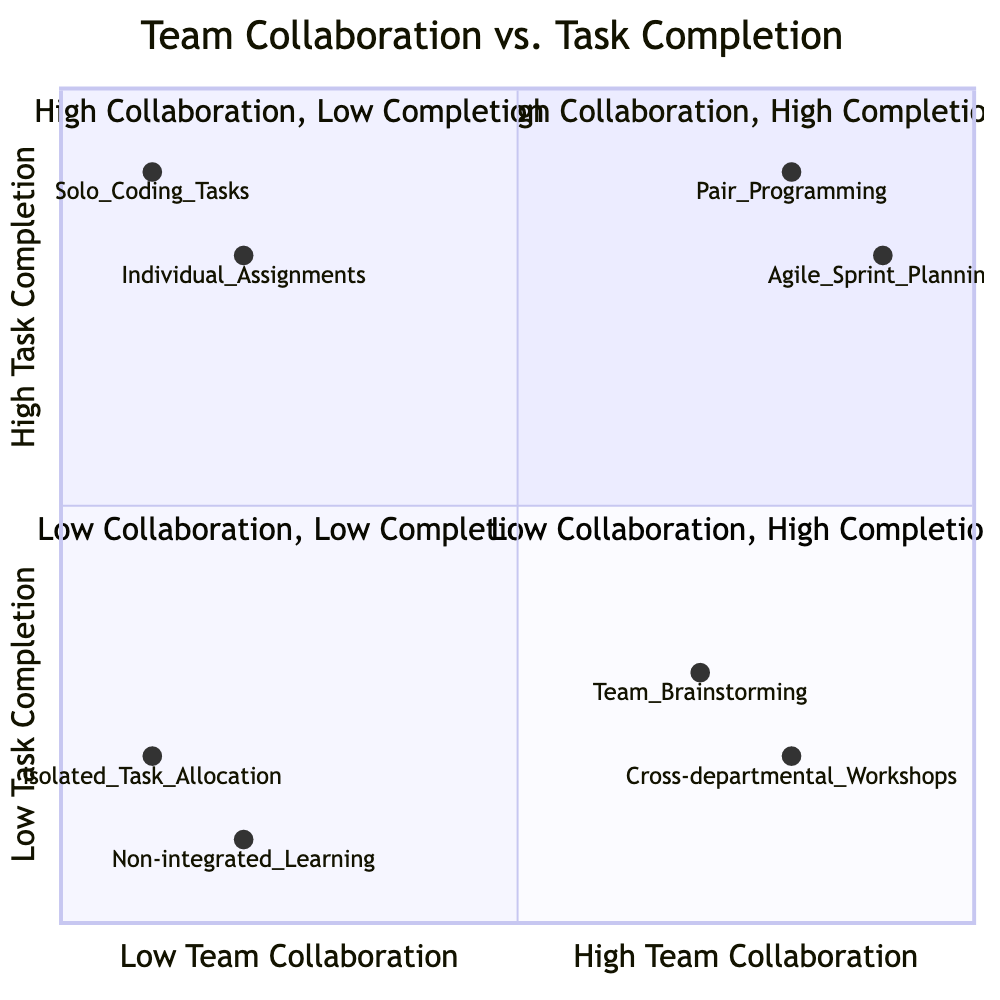What elements are in the "High Team Collaboration, High Task Completion" quadrant? In the "High Team Collaboration, High Task Completion" quadrant, the elements listed are "Pair Programming" and "Agile Sprint Planning".
Answer: Pair Programming, Agile Sprint Planning What does "Team Brainstorming Sessions" represent in terms of task completion? "Team Brainstorming Sessions" is categorized in the "High Team Collaboration, Low Task Completion" quadrant, indicating it may enhance creativity but can delay task completion.
Answer: Low Task Completion Which element is positioned at the coordinates [0.2, 0.1]? The element at [0.2, 0.1] is "Non-integrated Learning and Development". This is determined by evaluating the position on the diagram grid corresponding to that coordinate.
Answer: Non-integrated Learning and Development How many elements are there in the "Low Team Collaboration, High Task Completion" quadrant? The "Low Team Collaboration, High Task Completion" quadrant contains two elements: "Individual Assignments" and "Solo Coding Tasks".
Answer: 2 Which quadrant contains "Cross-departmental Workshops"? "Cross-departmental Workshops" is located in the "High Team Collaboration, Low Task Completion" quadrant, based on its collaboration and completion scores that correspond to that specific area.
Answer: High Team Collaboration, Low Task Completion What is the relationship between "Isolated Task Allocation" and "Non-integrated Learning and Development"? Both "Isolated Task Allocation" and "Non-integrated Learning and Development" are located in the "Low Team Collaboration, Low Task Completion" quadrant, suggesting they share similar characteristics of low collaboration and completion.
Answer: Same quadrant Which element has the highest task completion score in the quadrants? "Pair Programming" has the highest task completion score at 0.9, as indicated by its position in the chart.
Answer: Pair Programming What does the "Low Team Collaboration, Low Task Completion" quadrant indicate about team dynamics? This quadrant suggests a lack of synergy and coordination among team members, leading to both delays and inefficiencies in task completion.
Answer: Poor team dynamics 